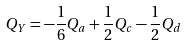Convert formula to latex. <formula><loc_0><loc_0><loc_500><loc_500>Q _ { Y } = - \frac { 1 } { 6 } Q _ { a } + \frac { 1 } { 2 } Q _ { c } - \frac { 1 } { 2 } Q _ { d }</formula> 